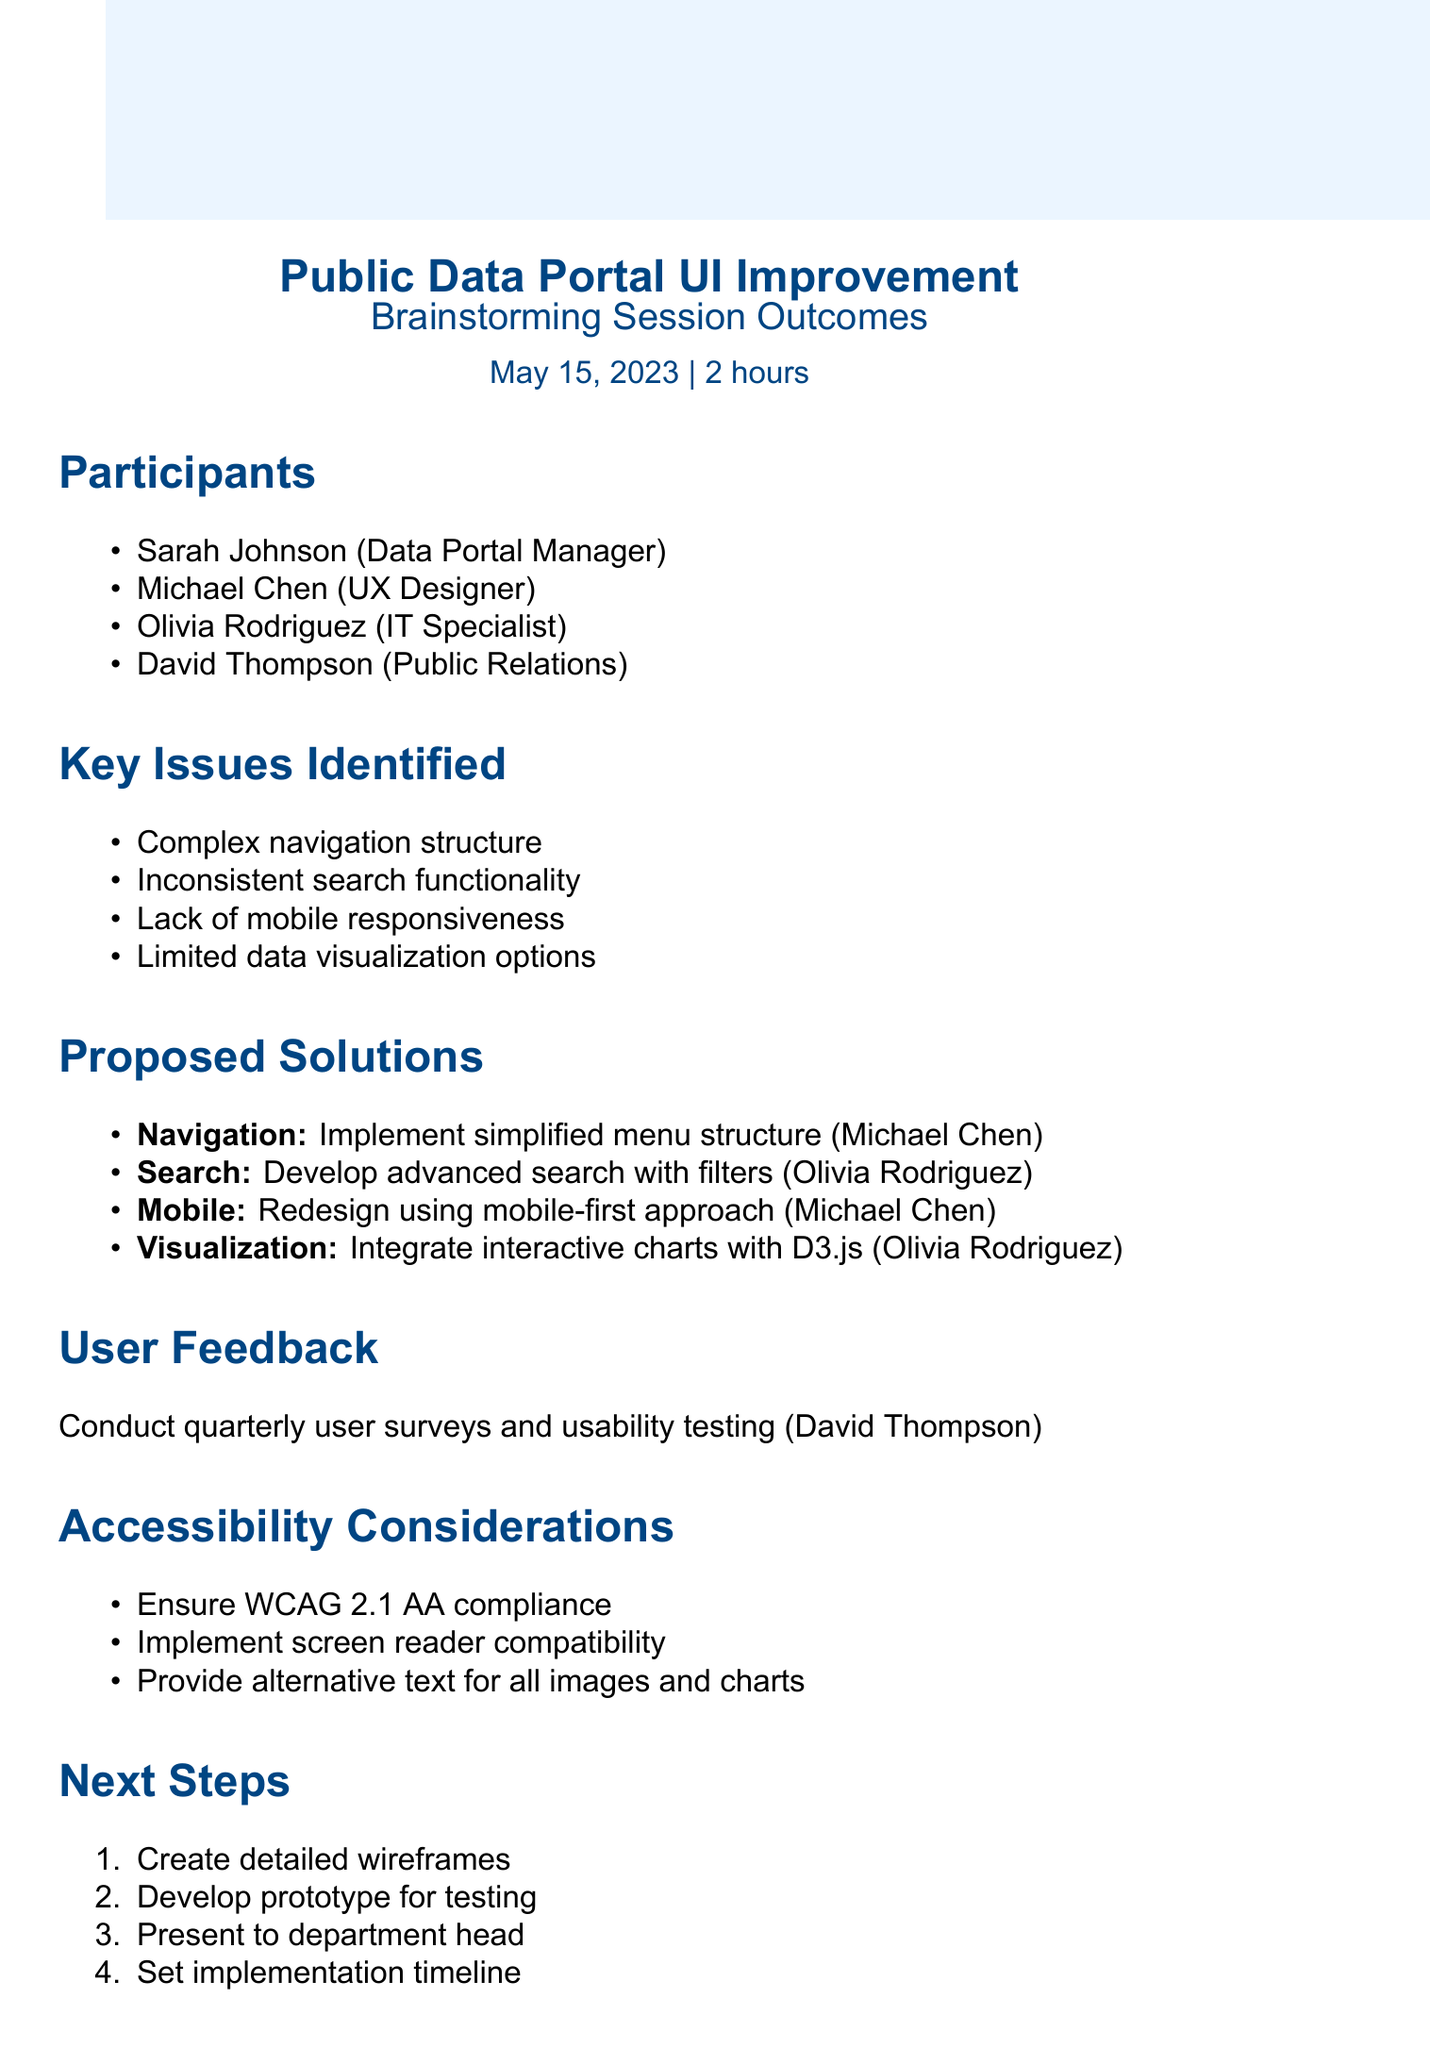What was the date of the brainstorming session? The date is explicitly stated in the document as May 15, 2023.
Answer: May 15, 2023 Who is responsible for improving the navigation structure? The document states that Michael Chen is responsible for implementing the navigation improvements.
Answer: Michael Chen What key issue related to mobile usability was identified? The document lists "Lack of mobile responsiveness" as a key issue related to mobile usability.
Answer: Lack of mobile responsiveness How many participants attended the brainstorming session? The document lists four participants, so the total is derived from that list.
Answer: Four What is the proposed solution for the inconsistent search functionality? The document states the solution is to "Develop an advanced search feature with filters and auto-suggestions."
Answer: Develop an advanced search feature with filters and auto-suggestions How often will user feedback be collected? The document indicates that user feedback will be collected quarterly.
Answer: Quarterly What is one of the expected outcomes of the proposed changes? The expected outcomes list includes "Increased user engagement" among other benefits.
Answer: Increased user engagement What type of compliance is mentioned under Accessibility Considerations? The document specifies "WCAG 2.1 AA compliance" as a requirement for accessibility.
Answer: WCAG 2.1 AA compliance How many next steps are outlined for the project? The document lists four distinct next steps to be taken.
Answer: Four 